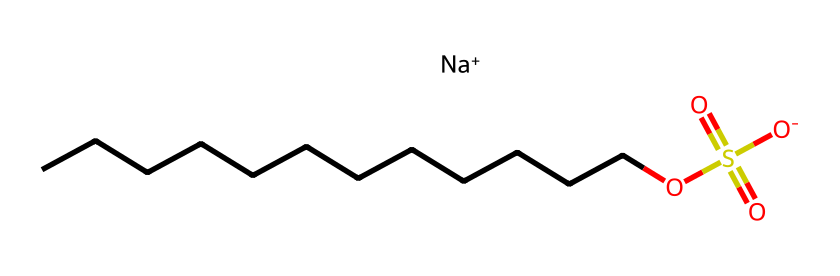How many carbon atoms are in sodium dodecyl sulfate? The SMILES representation shows "CCCCCCCCCCCC" which indicates there are twelve carbon atoms in a continuous chain.
Answer: twelve What type of functional group is present in the structure of sodium dodecyl sulfate? The SMILES includes "OS(=O)(=O)", indicating the presence of a sulfonate functional group (–SO3-), which is characteristic of surfactants like SDS.
Answer: sulfonate What is the charge of the sodium ion in sodium dodecyl sulfate? The notation "[Na+]" specifies that the sodium ion has a positive charge, which balances the negative charge from the sulfonate group.
Answer: positive How many oxygen atoms are present in sodium dodecyl sulfate? The "OS(=O)(=O)[O-]" part reveals that there are four oxygen atoms in total: one from the ether-like connection and three from the sulfonate group.
Answer: four Why does sodium dodecyl sulfate function as a surfactant? The long hydrophobic carbon chain (alkyl part) provides non-polar interaction, while the hydrophilic sulfonate head interacts with water, allowing for emulsification and stabilization of mixtures.
Answer: hydrophobic and hydrophilic regions What is the overall polarity of sodium dodecyl sulfate? The presence of a long hydrophobic tail and a polar sulfonate head indicates that the molecule is amphiphilic, giving it surfactant properties.
Answer: amphiphilic 